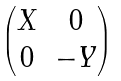<formula> <loc_0><loc_0><loc_500><loc_500>\begin{pmatrix} X & 0 \\ 0 & - Y \end{pmatrix}</formula> 